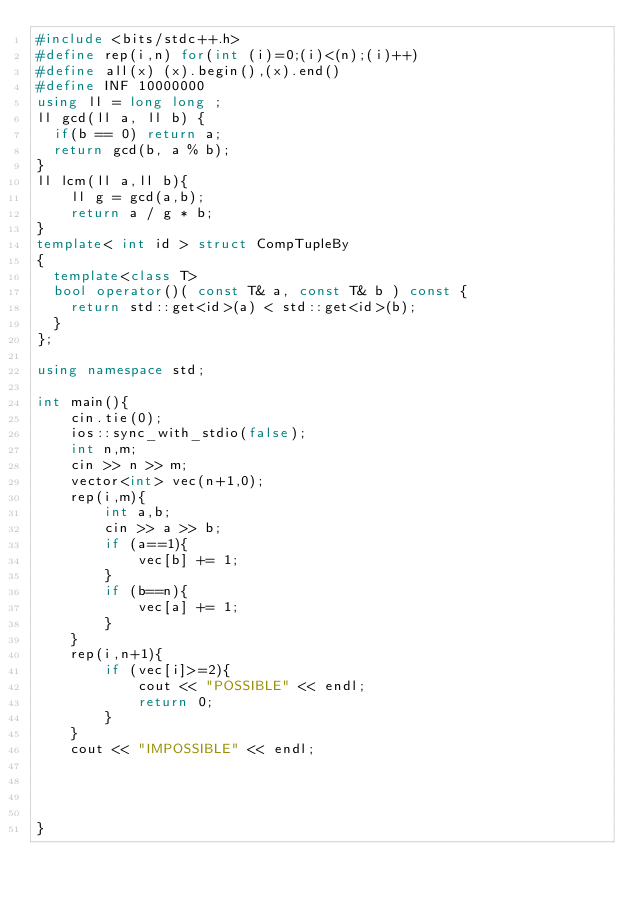Convert code to text. <code><loc_0><loc_0><loc_500><loc_500><_C++_>#include <bits/stdc++.h>
#define rep(i,n) for(int (i)=0;(i)<(n);(i)++)
#define all(x) (x).begin(),(x).end()
#define INF 10000000
using ll = long long ;
ll gcd(ll a, ll b) {
  if(b == 0) return a;
  return gcd(b, a % b);
}
ll lcm(ll a,ll b){
    ll g = gcd(a,b);
    return a / g * b;
}
template< int id > struct CompTupleBy
{
  template<class T> 
  bool operator()( const T& a, const T& b ) const {
    return std::get<id>(a) < std::get<id>(b);
  }
};

using namespace std;

int main(){
    cin.tie(0);
    ios::sync_with_stdio(false);
    int n,m;
    cin >> n >> m;
    vector<int> vec(n+1,0);
    rep(i,m){
        int a,b;
        cin >> a >> b;
        if (a==1){
            vec[b] += 1;
        }
        if (b==n){
            vec[a] += 1;
        }
    }
    rep(i,n+1){
        if (vec[i]>=2){
            cout << "POSSIBLE" << endl;
            return 0;
        }
    }
    cout << "IMPOSSIBLE" << endl;
    


        
}</code> 